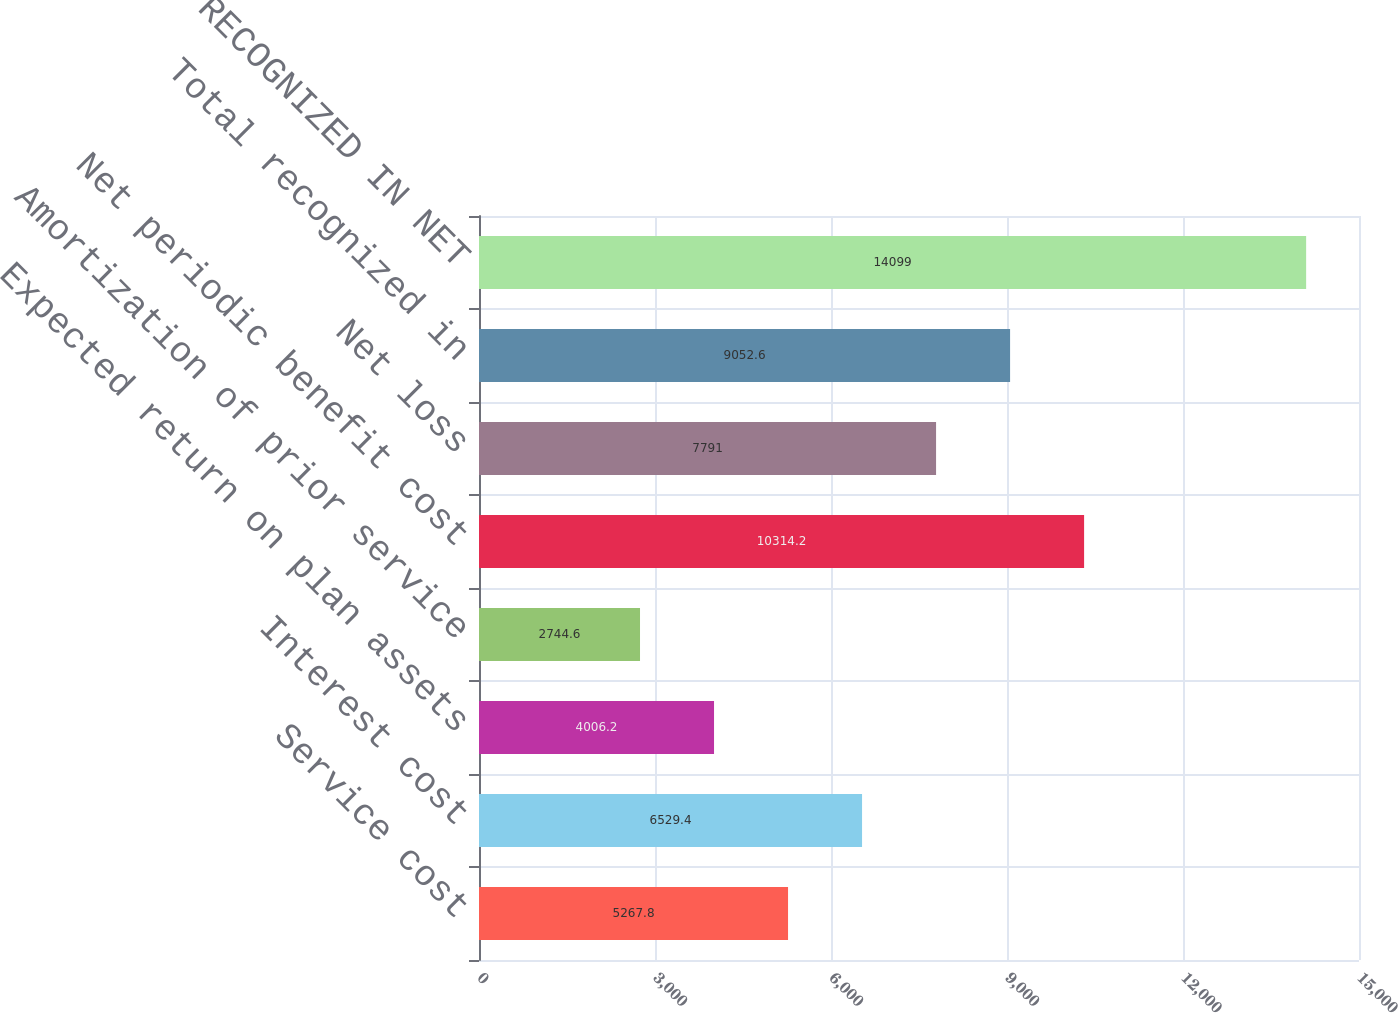Convert chart to OTSL. <chart><loc_0><loc_0><loc_500><loc_500><bar_chart><fcel>Service cost<fcel>Interest cost<fcel>Expected return on plan assets<fcel>Amortization of prior service<fcel>Net periodic benefit cost<fcel>Net loss<fcel>Total recognized in<fcel>TOTAL RECOGNIZED IN NET<nl><fcel>5267.8<fcel>6529.4<fcel>4006.2<fcel>2744.6<fcel>10314.2<fcel>7791<fcel>9052.6<fcel>14099<nl></chart> 